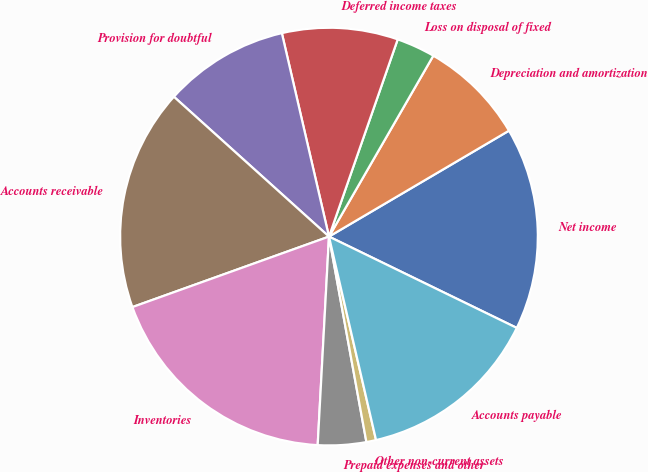<chart> <loc_0><loc_0><loc_500><loc_500><pie_chart><fcel>Net income<fcel>Depreciation and amortization<fcel>Loss on disposal of fixed<fcel>Deferred income taxes<fcel>Provision for doubtful<fcel>Accounts receivable<fcel>Inventories<fcel>Prepaid expenses and other<fcel>Other non-current assets<fcel>Accounts payable<nl><fcel>15.67%<fcel>8.21%<fcel>2.99%<fcel>8.96%<fcel>9.7%<fcel>17.16%<fcel>18.66%<fcel>3.73%<fcel>0.75%<fcel>14.18%<nl></chart> 